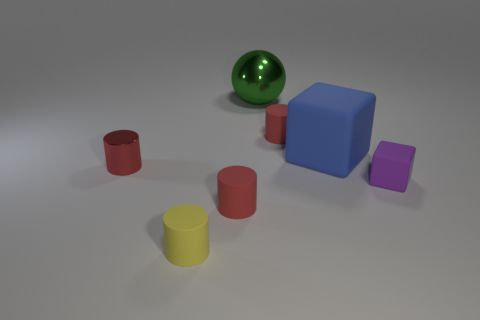Subtract all red cylinders. How many were subtracted if there are1red cylinders left? 2 Subtract all red metal cylinders. How many cylinders are left? 3 Add 2 large metal cylinders. How many objects exist? 9 Subtract all blocks. How many objects are left? 5 Subtract all yellow cylinders. How many cylinders are left? 3 Subtract 1 cylinders. How many cylinders are left? 3 Subtract all cyan blocks. Subtract all gray cylinders. How many blocks are left? 2 Subtract all green blocks. How many brown balls are left? 0 Subtract all big blue matte things. Subtract all small yellow blocks. How many objects are left? 6 Add 6 large objects. How many large objects are left? 8 